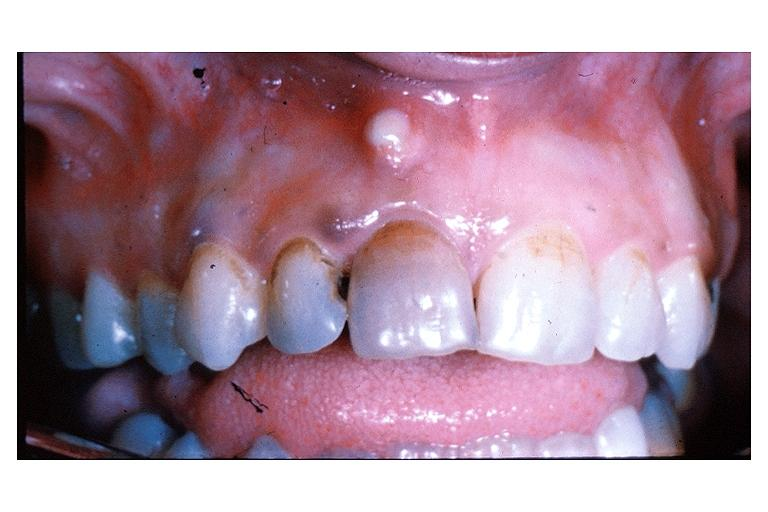what does this image show?
Answer the question using a single word or phrase. Parulis acute alveolar abscess 